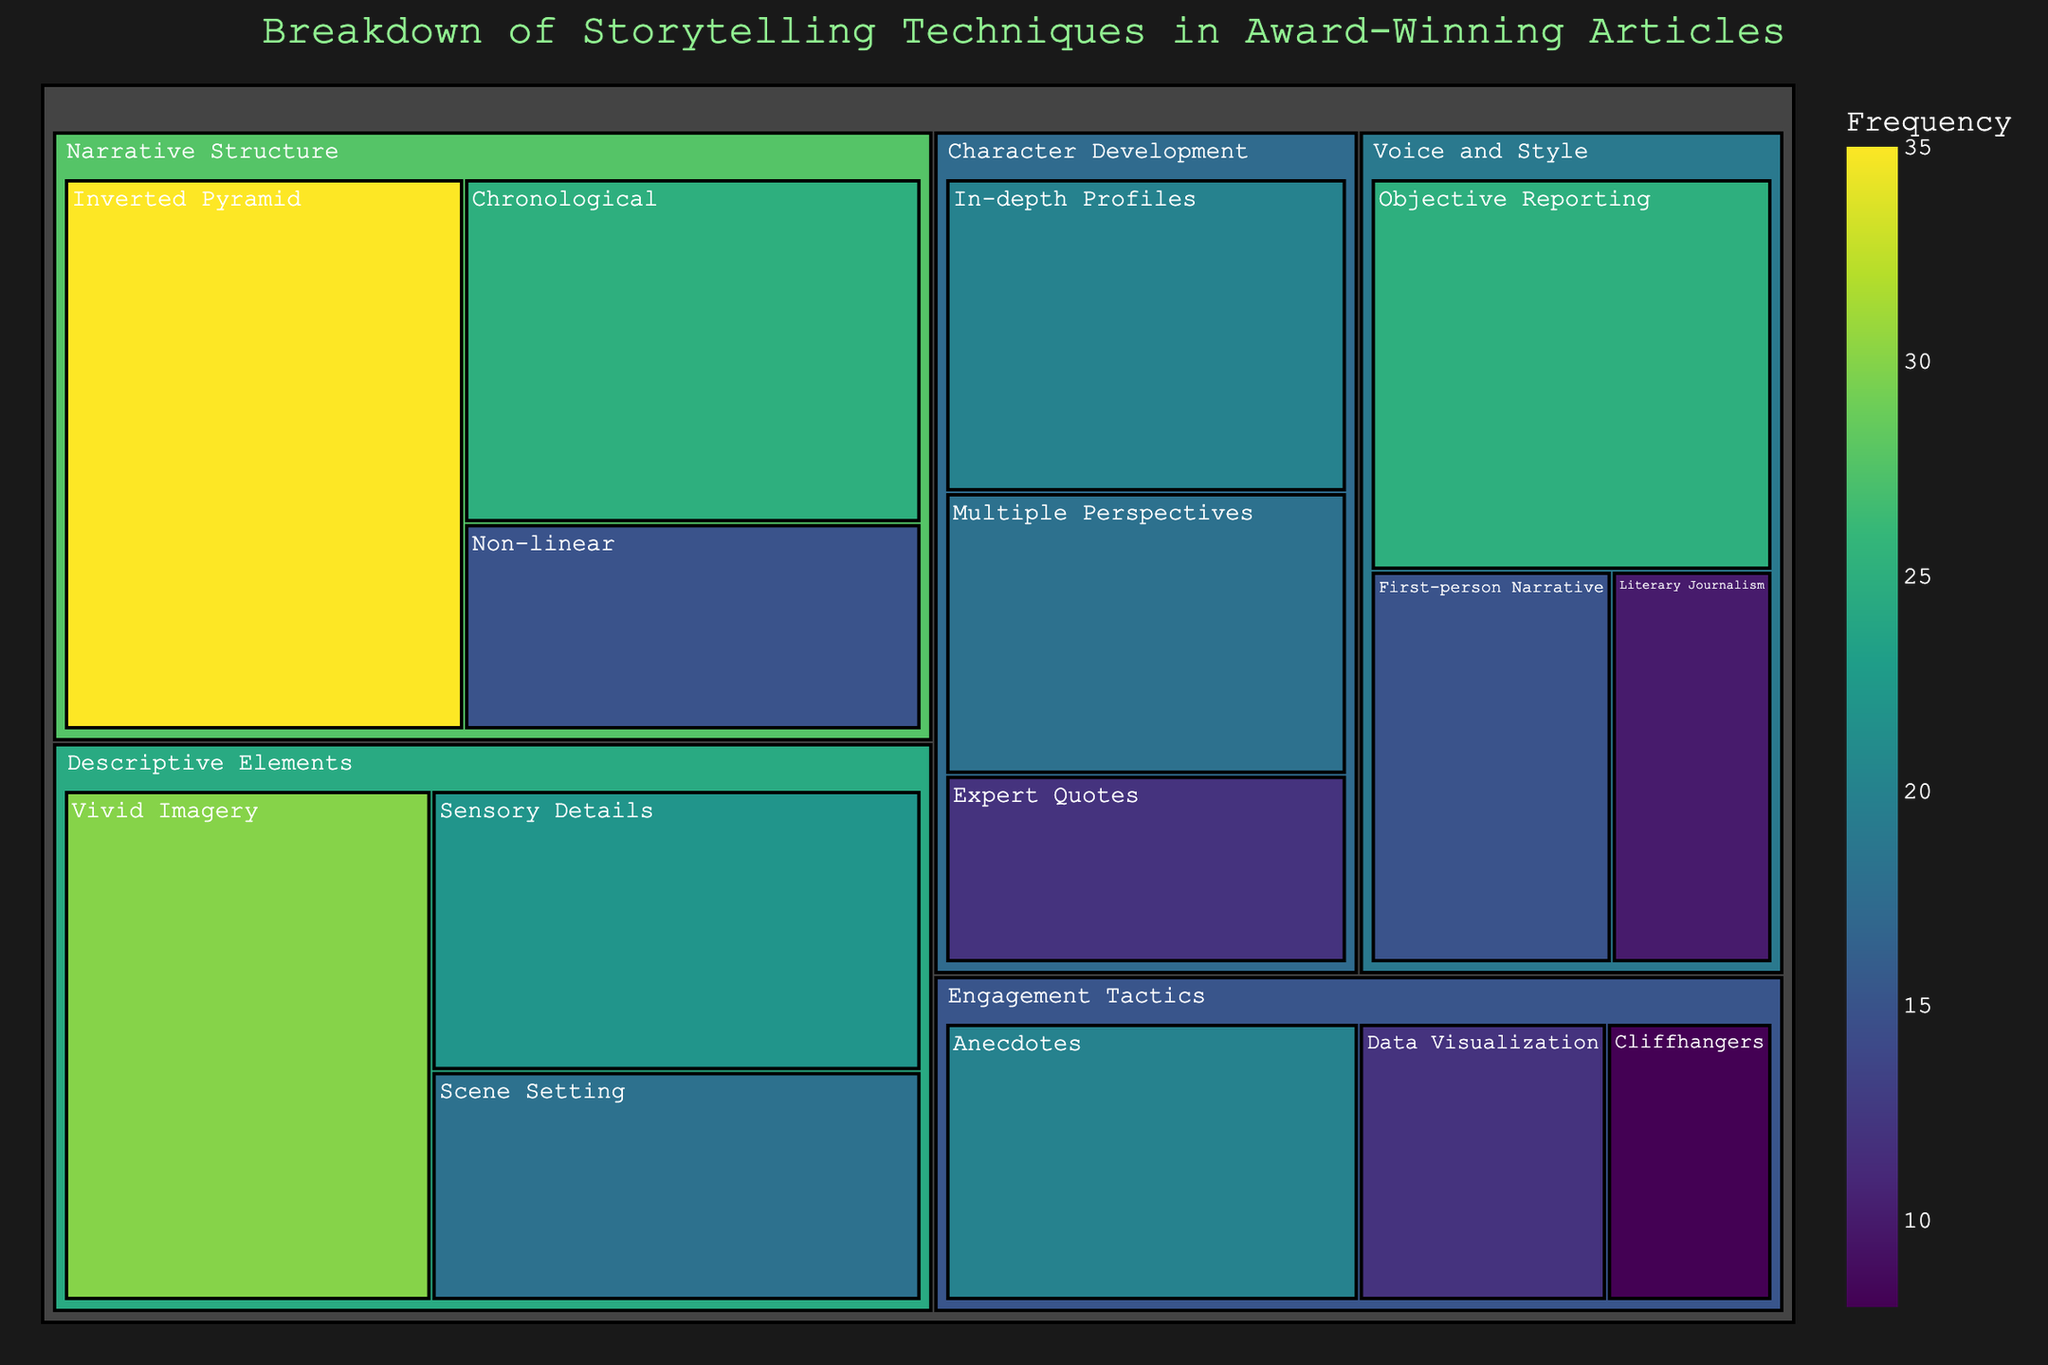What's the most frequently used technique? The plot shows the frequency of each storytelling technique. The one with the highest frequency value is the most frequently used. The highest value visible is for the "Inverted Pyramid" technique in the "Narrative Structure" category with a frequency of 35.
Answer: Inverted Pyramid Which category contains the least frequently used techniques overall? To find this, calculate the total frequency for each category by summing up the frequencies of all techniques in each category. Compare the sums. In this case, "Engagement Tactics" has the fewest: Cliffhangers (8) + Anecdotes (20) + Data Visualization (12) = 40.
Answer: Engagement Tactics How does the frequency of "Objective Reporting" compare to "First-person Narrative"? Observe the frequency values for both techniques in the "Voice and Style" category. "Objective Reporting" has a frequency of 25, and "First-person Narrative" has a frequency of 15, meaning "Objective Reporting" is used more often.
Answer: Objective Reporting is more frequent What is the total frequency of techniques under "Character Development"? Sum the frequencies of all listed techniques under "Character Development": In-depth Profiles (20) + Multiple Perspectives (18) + Expert Quotes (12). This totals 50.
Answer: 50 Which descriptive element is used the most? Look at the frequencies of techniques under the "Descriptive Elements" category. The technique with the highest frequency is "Vivid Imagery" with a frequency of 30.
Answer: Vivid Imagery What is the least common technique in this dataset? Identify the technique with the smallest frequency across all categories. "Cliffhangers" under "Engagement Tactics" has the smallest frequency value of 8.
Answer: Cliffhangers Compare the usage of "Chronological" and "Non-linear" techniques in the "Narrative Structure" category. Which is used more? Check the frequency values for both techniques. "Chronological" has a frequency of 25, while "Non-linear" has a frequency of 15. Therefore, "Chronological" is used more.
Answer: Chronological What is the total frequency of all techniques combined? Sum the frequencies of all techniques across all categories: 35 + 25 + 15 + 20 + 18 + 12 + 30 + 22 + 18 + 15 + 25 + 10 + 8 + 20 + 12. The total is 285.
Answer: 285 